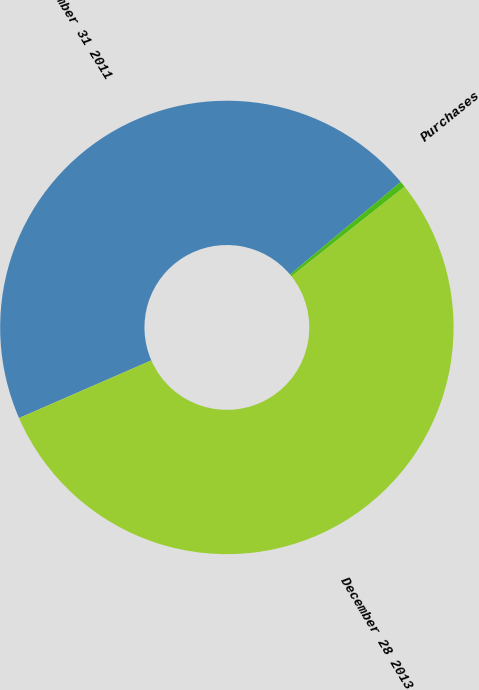Convert chart. <chart><loc_0><loc_0><loc_500><loc_500><pie_chart><fcel>December 31 2011<fcel>Purchases<fcel>December 28 2013<nl><fcel>45.45%<fcel>0.43%<fcel>54.11%<nl></chart> 